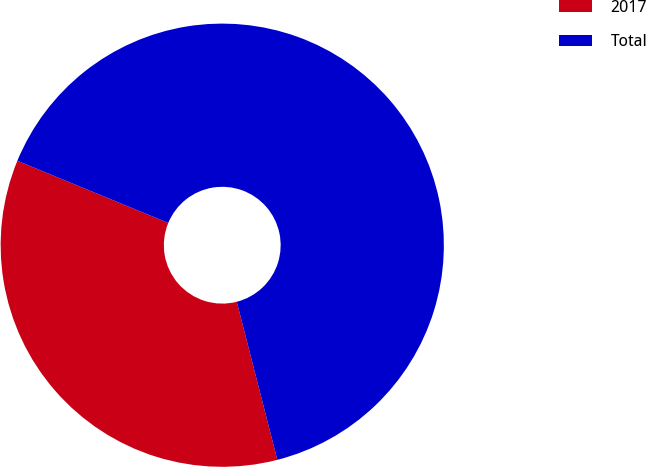<chart> <loc_0><loc_0><loc_500><loc_500><pie_chart><fcel>2017<fcel>Total<nl><fcel>35.22%<fcel>64.78%<nl></chart> 